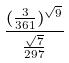Convert formula to latex. <formula><loc_0><loc_0><loc_500><loc_500>\frac { ( \frac { 3 } { 3 6 1 } ) ^ { \sqrt { 9 } } } { \frac { \sqrt { 7 } } { 2 9 7 } }</formula> 